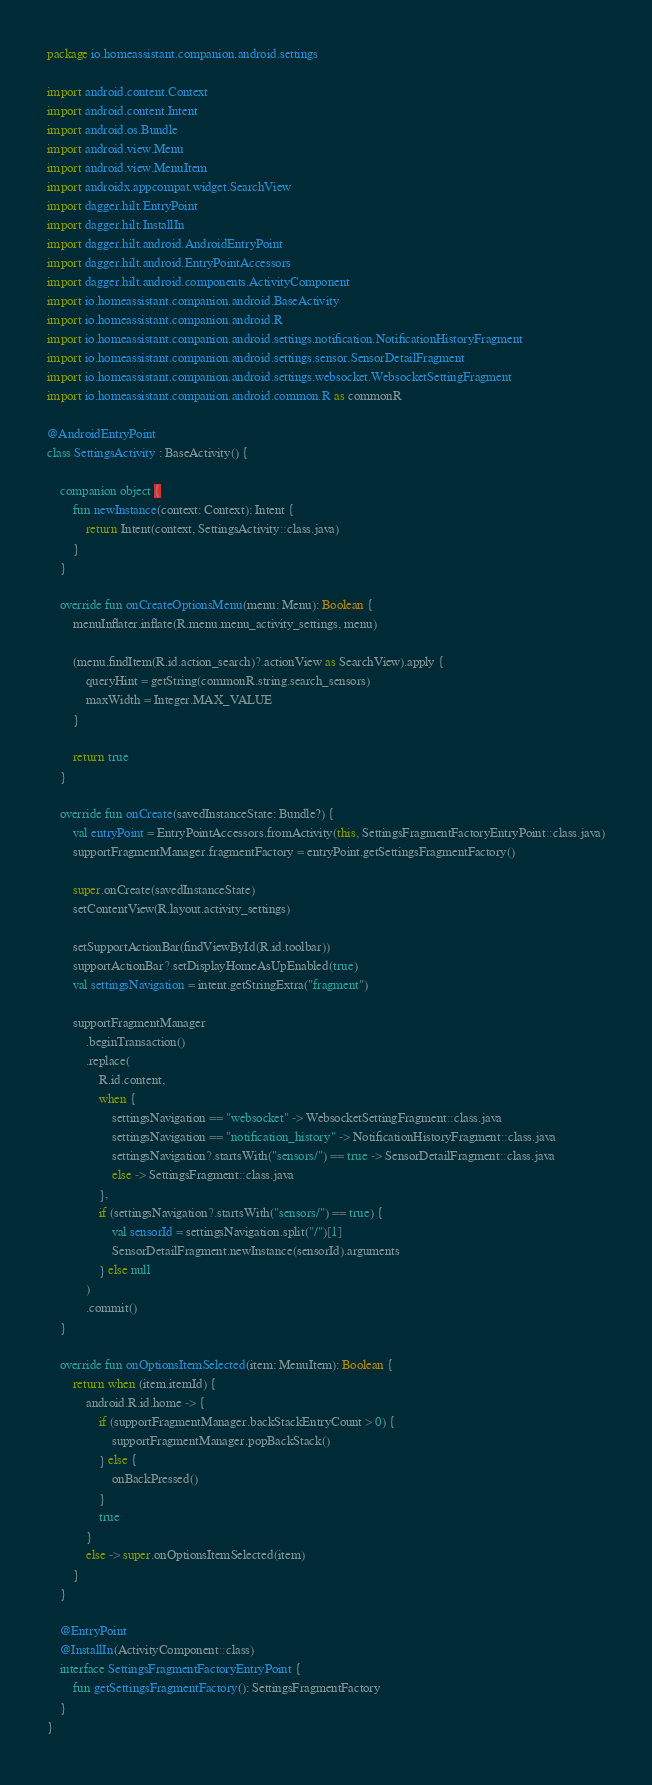<code> <loc_0><loc_0><loc_500><loc_500><_Kotlin_>package io.homeassistant.companion.android.settings

import android.content.Context
import android.content.Intent
import android.os.Bundle
import android.view.Menu
import android.view.MenuItem
import androidx.appcompat.widget.SearchView
import dagger.hilt.EntryPoint
import dagger.hilt.InstallIn
import dagger.hilt.android.AndroidEntryPoint
import dagger.hilt.android.EntryPointAccessors
import dagger.hilt.android.components.ActivityComponent
import io.homeassistant.companion.android.BaseActivity
import io.homeassistant.companion.android.R
import io.homeassistant.companion.android.settings.notification.NotificationHistoryFragment
import io.homeassistant.companion.android.settings.sensor.SensorDetailFragment
import io.homeassistant.companion.android.settings.websocket.WebsocketSettingFragment
import io.homeassistant.companion.android.common.R as commonR

@AndroidEntryPoint
class SettingsActivity : BaseActivity() {

    companion object {
        fun newInstance(context: Context): Intent {
            return Intent(context, SettingsActivity::class.java)
        }
    }

    override fun onCreateOptionsMenu(menu: Menu): Boolean {
        menuInflater.inflate(R.menu.menu_activity_settings, menu)

        (menu.findItem(R.id.action_search)?.actionView as SearchView).apply {
            queryHint = getString(commonR.string.search_sensors)
            maxWidth = Integer.MAX_VALUE
        }

        return true
    }

    override fun onCreate(savedInstanceState: Bundle?) {
        val entryPoint = EntryPointAccessors.fromActivity(this, SettingsFragmentFactoryEntryPoint::class.java)
        supportFragmentManager.fragmentFactory = entryPoint.getSettingsFragmentFactory()

        super.onCreate(savedInstanceState)
        setContentView(R.layout.activity_settings)

        setSupportActionBar(findViewById(R.id.toolbar))
        supportActionBar?.setDisplayHomeAsUpEnabled(true)
        val settingsNavigation = intent.getStringExtra("fragment")

        supportFragmentManager
            .beginTransaction()
            .replace(
                R.id.content,
                when {
                    settingsNavigation == "websocket" -> WebsocketSettingFragment::class.java
                    settingsNavigation == "notification_history" -> NotificationHistoryFragment::class.java
                    settingsNavigation?.startsWith("sensors/") == true -> SensorDetailFragment::class.java
                    else -> SettingsFragment::class.java
                },
                if (settingsNavigation?.startsWith("sensors/") == true) {
                    val sensorId = settingsNavigation.split("/")[1]
                    SensorDetailFragment.newInstance(sensorId).arguments
                } else null
            )
            .commit()
    }

    override fun onOptionsItemSelected(item: MenuItem): Boolean {
        return when (item.itemId) {
            android.R.id.home -> {
                if (supportFragmentManager.backStackEntryCount > 0) {
                    supportFragmentManager.popBackStack()
                } else {
                    onBackPressed()
                }
                true
            }
            else -> super.onOptionsItemSelected(item)
        }
    }

    @EntryPoint
    @InstallIn(ActivityComponent::class)
    interface SettingsFragmentFactoryEntryPoint {
        fun getSettingsFragmentFactory(): SettingsFragmentFactory
    }
}
</code> 